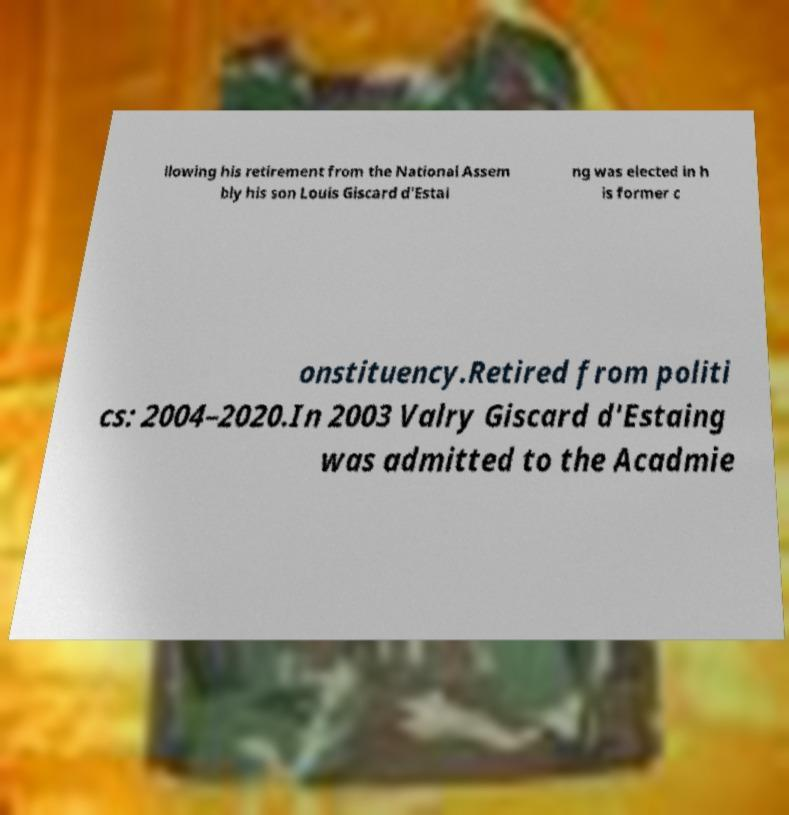Can you accurately transcribe the text from the provided image for me? llowing his retirement from the National Assem bly his son Louis Giscard d'Estai ng was elected in h is former c onstituency.Retired from politi cs: 2004–2020.In 2003 Valry Giscard d'Estaing was admitted to the Acadmie 